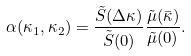<formula> <loc_0><loc_0><loc_500><loc_500>\alpha ( { \kappa _ { 1 } , \kappa _ { 2 } ) = \frac { \tilde { S } ( \Delta \kappa ) } { \tilde { S } ( 0 ) } \frac { \tilde { \mu } ( \bar { \kappa } ) } { \tilde { \mu } ( 0 ) } } .</formula> 